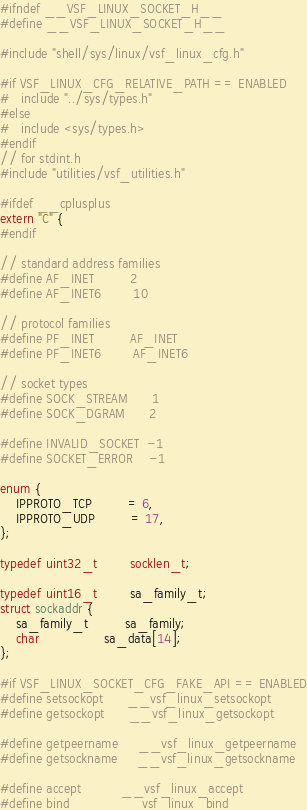Convert code to text. <code><loc_0><loc_0><loc_500><loc_500><_C_>#ifndef __VSF_LINUX_SOCKET_H__
#define __VSF_LINUX_SOCKET_H__

#include "shell/sys/linux/vsf_linux_cfg.h"

#if VSF_LINUX_CFG_RELATIVE_PATH == ENABLED
#   include "../sys/types.h"
#else
#   include <sys/types.h>
#endif
// for stdint.h
#include "utilities/vsf_utilities.h"

#ifdef __cplusplus
extern "C" {
#endif

// standard address families
#define AF_INET         2
#define AF_INET6        10

// protocol families
#define PF_INET         AF_INET
#define PF_INET6        AF_INET6

// socket types
#define SOCK_STREAM	    1
#define SOCK_DGRAM      2

#define INVALID_SOCKET  -1
#define SOCKET_ERROR    -1

enum {
    IPPROTO_TCP         = 6,
    IPPROTO_UDP         = 17,
};

typedef uint32_t        socklen_t;

typedef uint16_t        sa_family_t;
struct sockaddr {
    sa_family_t         sa_family;
    char                sa_data[14];
};

#if VSF_LINUX_SOCKET_CFG_FAKE_API == ENABLED
#define setsockopt      __vsf_linux_setsockopt
#define getsockopt      __vsf_linux_getsockopt

#define getpeername     __vsf_linux_getpeername
#define getsockname     __vsf_linux_getsockname

#define accept          __vsf_linux_accept
#define bind            __vsf_linux_bind</code> 